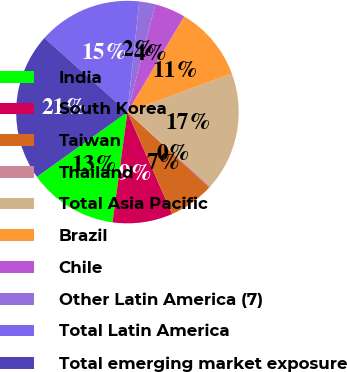Convert chart to OTSL. <chart><loc_0><loc_0><loc_500><loc_500><pie_chart><fcel>India<fcel>South Korea<fcel>Taiwan<fcel>Thailand<fcel>Total Asia Pacific<fcel>Brazil<fcel>Chile<fcel>Other Latin America (7)<fcel>Total Latin America<fcel>Total emerging market exposure<nl><fcel>12.98%<fcel>8.72%<fcel>6.6%<fcel>0.22%<fcel>17.23%<fcel>10.85%<fcel>4.47%<fcel>2.35%<fcel>15.1%<fcel>21.48%<nl></chart> 